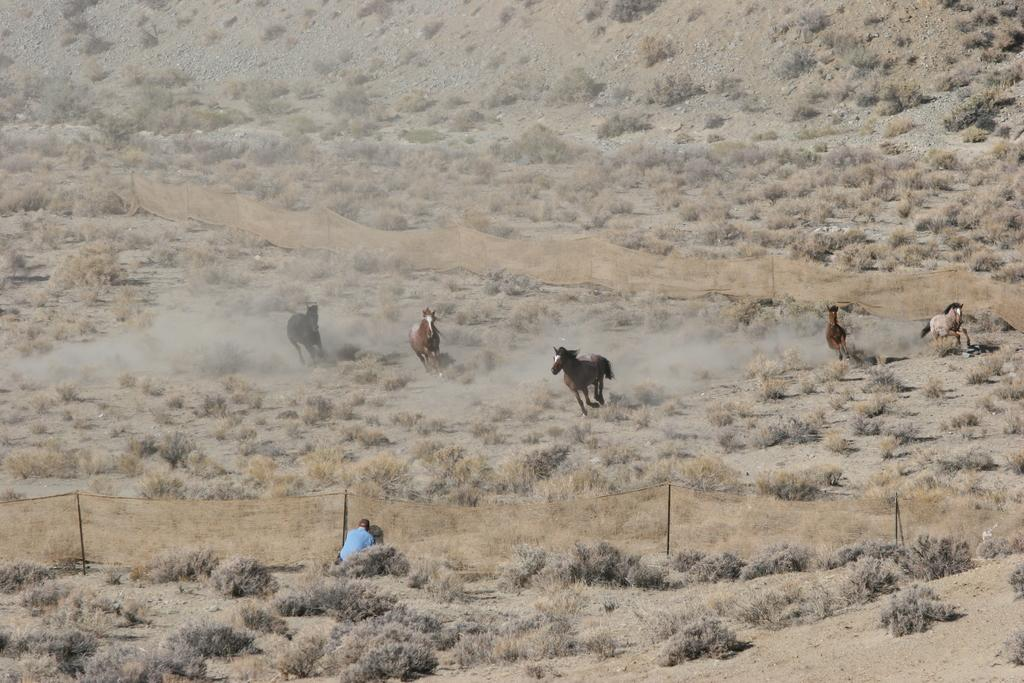What is the person in the image doing? There is a person sitting in the image. What other living creatures are present in the image? There are animals in the image. What type of natural vegetation can be seen in the image? There is dried grass in the image. What type of geological formation is visible in the image? There are rocks in the image. What type of barrier is present in the image? There is fencing in the image. What type of quill is the person using to write in the image? There is no quill present in the image, and the person is not writing. Can you see any bees buzzing around the animals in the image? There are no bees visible in the image. What type of container is holding the animals in the image? There is no container holding the animals in the image; they are freely roaming. 